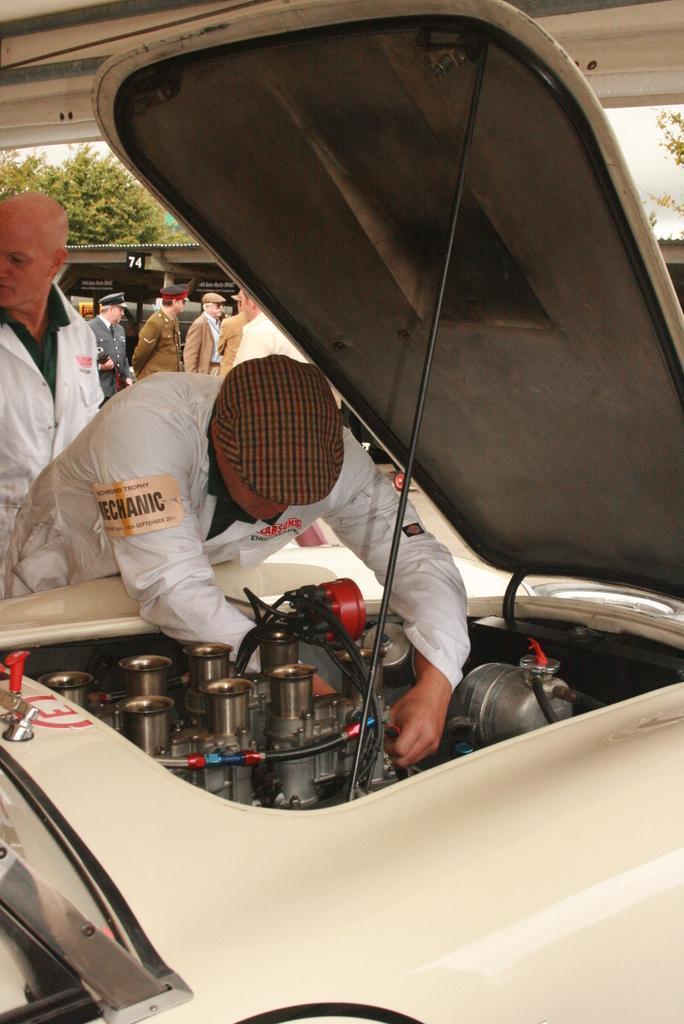Please provide a concise description of this image. In this picture we can see some people standing here, there is a vehicle in the front, we can see a bonnet here, there is a vehicle's engine here, a man in the front wore a cap, in the background we can see a tree. 